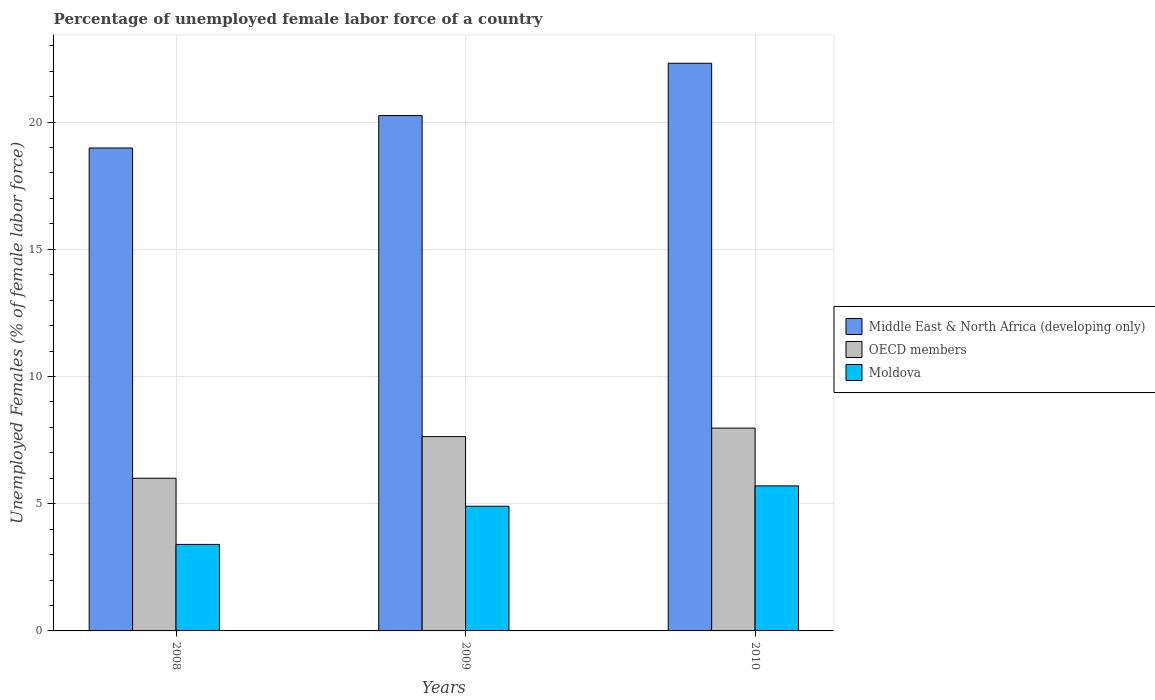Are the number of bars per tick equal to the number of legend labels?
Your answer should be compact. Yes. Are the number of bars on each tick of the X-axis equal?
Provide a succinct answer. Yes. How many bars are there on the 2nd tick from the left?
Provide a succinct answer. 3. How many bars are there on the 1st tick from the right?
Your answer should be compact. 3. What is the label of the 2nd group of bars from the left?
Keep it short and to the point. 2009. In how many cases, is the number of bars for a given year not equal to the number of legend labels?
Your answer should be very brief. 0. What is the percentage of unemployed female labor force in OECD members in 2008?
Give a very brief answer. 6. Across all years, what is the maximum percentage of unemployed female labor force in Moldova?
Ensure brevity in your answer.  5.7. Across all years, what is the minimum percentage of unemployed female labor force in Moldova?
Give a very brief answer. 3.4. In which year was the percentage of unemployed female labor force in Middle East & North Africa (developing only) maximum?
Your answer should be compact. 2010. What is the total percentage of unemployed female labor force in Middle East & North Africa (developing only) in the graph?
Make the answer very short. 61.54. What is the difference between the percentage of unemployed female labor force in Moldova in 2009 and that in 2010?
Offer a very short reply. -0.8. What is the difference between the percentage of unemployed female labor force in Moldova in 2008 and the percentage of unemployed female labor force in OECD members in 2009?
Provide a short and direct response. -4.24. What is the average percentage of unemployed female labor force in Moldova per year?
Keep it short and to the point. 4.67. In the year 2010, what is the difference between the percentage of unemployed female labor force in Middle East & North Africa (developing only) and percentage of unemployed female labor force in OECD members?
Your answer should be very brief. 14.34. In how many years, is the percentage of unemployed female labor force in Moldova greater than 19 %?
Your response must be concise. 0. What is the ratio of the percentage of unemployed female labor force in OECD members in 2008 to that in 2010?
Ensure brevity in your answer.  0.75. Is the percentage of unemployed female labor force in OECD members in 2008 less than that in 2009?
Offer a very short reply. Yes. Is the difference between the percentage of unemployed female labor force in Middle East & North Africa (developing only) in 2008 and 2010 greater than the difference between the percentage of unemployed female labor force in OECD members in 2008 and 2010?
Your response must be concise. No. What is the difference between the highest and the second highest percentage of unemployed female labor force in Middle East & North Africa (developing only)?
Your answer should be very brief. 2.06. What is the difference between the highest and the lowest percentage of unemployed female labor force in Middle East & North Africa (developing only)?
Make the answer very short. 3.33. In how many years, is the percentage of unemployed female labor force in Moldova greater than the average percentage of unemployed female labor force in Moldova taken over all years?
Provide a short and direct response. 2. Is the sum of the percentage of unemployed female labor force in OECD members in 2008 and 2009 greater than the maximum percentage of unemployed female labor force in Moldova across all years?
Provide a short and direct response. Yes. What does the 1st bar from the left in 2010 represents?
Your answer should be very brief. Middle East & North Africa (developing only). Is it the case that in every year, the sum of the percentage of unemployed female labor force in Moldova and percentage of unemployed female labor force in Middle East & North Africa (developing only) is greater than the percentage of unemployed female labor force in OECD members?
Your response must be concise. Yes. How many bars are there?
Provide a short and direct response. 9. Are the values on the major ticks of Y-axis written in scientific E-notation?
Your response must be concise. No. Where does the legend appear in the graph?
Offer a terse response. Center right. What is the title of the graph?
Offer a terse response. Percentage of unemployed female labor force of a country. What is the label or title of the Y-axis?
Your response must be concise. Unemployed Females (% of female labor force). What is the Unemployed Females (% of female labor force) of Middle East & North Africa (developing only) in 2008?
Provide a succinct answer. 18.98. What is the Unemployed Females (% of female labor force) of OECD members in 2008?
Offer a very short reply. 6. What is the Unemployed Females (% of female labor force) of Moldova in 2008?
Offer a terse response. 3.4. What is the Unemployed Females (% of female labor force) in Middle East & North Africa (developing only) in 2009?
Provide a succinct answer. 20.25. What is the Unemployed Females (% of female labor force) of OECD members in 2009?
Your answer should be very brief. 7.64. What is the Unemployed Females (% of female labor force) in Moldova in 2009?
Provide a short and direct response. 4.9. What is the Unemployed Females (% of female labor force) of Middle East & North Africa (developing only) in 2010?
Provide a short and direct response. 22.31. What is the Unemployed Females (% of female labor force) of OECD members in 2010?
Your answer should be very brief. 7.97. What is the Unemployed Females (% of female labor force) in Moldova in 2010?
Provide a short and direct response. 5.7. Across all years, what is the maximum Unemployed Females (% of female labor force) in Middle East & North Africa (developing only)?
Provide a short and direct response. 22.31. Across all years, what is the maximum Unemployed Females (% of female labor force) of OECD members?
Ensure brevity in your answer.  7.97. Across all years, what is the maximum Unemployed Females (% of female labor force) of Moldova?
Provide a short and direct response. 5.7. Across all years, what is the minimum Unemployed Females (% of female labor force) of Middle East & North Africa (developing only)?
Make the answer very short. 18.98. Across all years, what is the minimum Unemployed Females (% of female labor force) of OECD members?
Make the answer very short. 6. Across all years, what is the minimum Unemployed Females (% of female labor force) of Moldova?
Make the answer very short. 3.4. What is the total Unemployed Females (% of female labor force) in Middle East & North Africa (developing only) in the graph?
Provide a short and direct response. 61.54. What is the total Unemployed Females (% of female labor force) in OECD members in the graph?
Your answer should be very brief. 21.61. What is the total Unemployed Females (% of female labor force) of Moldova in the graph?
Offer a terse response. 14. What is the difference between the Unemployed Females (% of female labor force) of Middle East & North Africa (developing only) in 2008 and that in 2009?
Give a very brief answer. -1.27. What is the difference between the Unemployed Females (% of female labor force) in OECD members in 2008 and that in 2009?
Your answer should be very brief. -1.64. What is the difference between the Unemployed Females (% of female labor force) of Moldova in 2008 and that in 2009?
Ensure brevity in your answer.  -1.5. What is the difference between the Unemployed Females (% of female labor force) of Middle East & North Africa (developing only) in 2008 and that in 2010?
Keep it short and to the point. -3.33. What is the difference between the Unemployed Females (% of female labor force) in OECD members in 2008 and that in 2010?
Your answer should be compact. -1.97. What is the difference between the Unemployed Females (% of female labor force) in Middle East & North Africa (developing only) in 2009 and that in 2010?
Your response must be concise. -2.06. What is the difference between the Unemployed Females (% of female labor force) of OECD members in 2009 and that in 2010?
Give a very brief answer. -0.33. What is the difference between the Unemployed Females (% of female labor force) of Middle East & North Africa (developing only) in 2008 and the Unemployed Females (% of female labor force) of OECD members in 2009?
Make the answer very short. 11.34. What is the difference between the Unemployed Females (% of female labor force) of Middle East & North Africa (developing only) in 2008 and the Unemployed Females (% of female labor force) of Moldova in 2009?
Offer a very short reply. 14.08. What is the difference between the Unemployed Females (% of female labor force) of OECD members in 2008 and the Unemployed Females (% of female labor force) of Moldova in 2009?
Offer a terse response. 1.1. What is the difference between the Unemployed Females (% of female labor force) in Middle East & North Africa (developing only) in 2008 and the Unemployed Females (% of female labor force) in OECD members in 2010?
Your response must be concise. 11.01. What is the difference between the Unemployed Females (% of female labor force) of Middle East & North Africa (developing only) in 2008 and the Unemployed Females (% of female labor force) of Moldova in 2010?
Your answer should be very brief. 13.28. What is the difference between the Unemployed Females (% of female labor force) of OECD members in 2008 and the Unemployed Females (% of female labor force) of Moldova in 2010?
Ensure brevity in your answer.  0.3. What is the difference between the Unemployed Females (% of female labor force) of Middle East & North Africa (developing only) in 2009 and the Unemployed Females (% of female labor force) of OECD members in 2010?
Your answer should be very brief. 12.28. What is the difference between the Unemployed Females (% of female labor force) in Middle East & North Africa (developing only) in 2009 and the Unemployed Females (% of female labor force) in Moldova in 2010?
Offer a terse response. 14.55. What is the difference between the Unemployed Females (% of female labor force) in OECD members in 2009 and the Unemployed Females (% of female labor force) in Moldova in 2010?
Provide a succinct answer. 1.94. What is the average Unemployed Females (% of female labor force) in Middle East & North Africa (developing only) per year?
Keep it short and to the point. 20.51. What is the average Unemployed Females (% of female labor force) in OECD members per year?
Make the answer very short. 7.2. What is the average Unemployed Females (% of female labor force) of Moldova per year?
Your answer should be very brief. 4.67. In the year 2008, what is the difference between the Unemployed Females (% of female labor force) of Middle East & North Africa (developing only) and Unemployed Females (% of female labor force) of OECD members?
Your answer should be compact. 12.98. In the year 2008, what is the difference between the Unemployed Females (% of female labor force) of Middle East & North Africa (developing only) and Unemployed Females (% of female labor force) of Moldova?
Offer a very short reply. 15.58. In the year 2008, what is the difference between the Unemployed Females (% of female labor force) in OECD members and Unemployed Females (% of female labor force) in Moldova?
Make the answer very short. 2.6. In the year 2009, what is the difference between the Unemployed Females (% of female labor force) of Middle East & North Africa (developing only) and Unemployed Females (% of female labor force) of OECD members?
Your response must be concise. 12.62. In the year 2009, what is the difference between the Unemployed Females (% of female labor force) of Middle East & North Africa (developing only) and Unemployed Females (% of female labor force) of Moldova?
Give a very brief answer. 15.35. In the year 2009, what is the difference between the Unemployed Females (% of female labor force) in OECD members and Unemployed Females (% of female labor force) in Moldova?
Your response must be concise. 2.74. In the year 2010, what is the difference between the Unemployed Females (% of female labor force) of Middle East & North Africa (developing only) and Unemployed Females (% of female labor force) of OECD members?
Provide a short and direct response. 14.34. In the year 2010, what is the difference between the Unemployed Females (% of female labor force) of Middle East & North Africa (developing only) and Unemployed Females (% of female labor force) of Moldova?
Ensure brevity in your answer.  16.61. In the year 2010, what is the difference between the Unemployed Females (% of female labor force) of OECD members and Unemployed Females (% of female labor force) of Moldova?
Provide a succinct answer. 2.27. What is the ratio of the Unemployed Females (% of female labor force) in Middle East & North Africa (developing only) in 2008 to that in 2009?
Provide a short and direct response. 0.94. What is the ratio of the Unemployed Females (% of female labor force) in OECD members in 2008 to that in 2009?
Provide a short and direct response. 0.79. What is the ratio of the Unemployed Females (% of female labor force) of Moldova in 2008 to that in 2009?
Keep it short and to the point. 0.69. What is the ratio of the Unemployed Females (% of female labor force) of Middle East & North Africa (developing only) in 2008 to that in 2010?
Keep it short and to the point. 0.85. What is the ratio of the Unemployed Females (% of female labor force) of OECD members in 2008 to that in 2010?
Provide a succinct answer. 0.75. What is the ratio of the Unemployed Females (% of female labor force) in Moldova in 2008 to that in 2010?
Your answer should be very brief. 0.6. What is the ratio of the Unemployed Females (% of female labor force) of Middle East & North Africa (developing only) in 2009 to that in 2010?
Make the answer very short. 0.91. What is the ratio of the Unemployed Females (% of female labor force) of OECD members in 2009 to that in 2010?
Make the answer very short. 0.96. What is the ratio of the Unemployed Females (% of female labor force) of Moldova in 2009 to that in 2010?
Provide a short and direct response. 0.86. What is the difference between the highest and the second highest Unemployed Females (% of female labor force) of Middle East & North Africa (developing only)?
Offer a terse response. 2.06. What is the difference between the highest and the second highest Unemployed Females (% of female labor force) in OECD members?
Your answer should be very brief. 0.33. What is the difference between the highest and the lowest Unemployed Females (% of female labor force) in Middle East & North Africa (developing only)?
Provide a succinct answer. 3.33. What is the difference between the highest and the lowest Unemployed Females (% of female labor force) of OECD members?
Give a very brief answer. 1.97. What is the difference between the highest and the lowest Unemployed Females (% of female labor force) in Moldova?
Give a very brief answer. 2.3. 